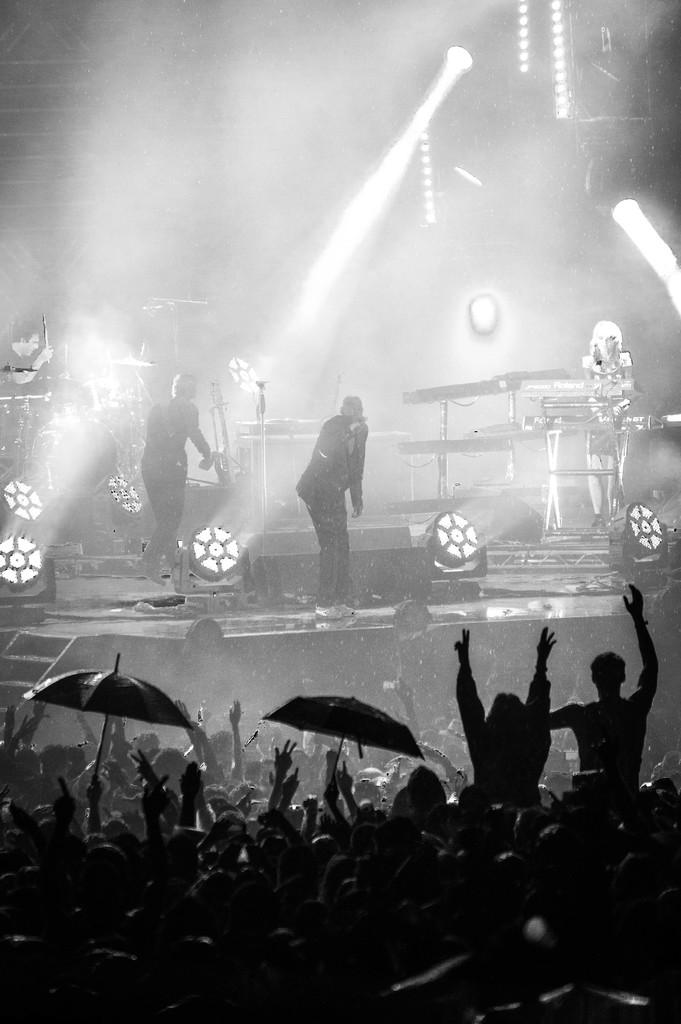How many people are in the image? There is a group of people in the image. What are some people doing in the image? Some people are holding umbrellas. What can be seen in the background of the image? Musical instruments, lights, and smoke are visible in the background. What type of club can be seen in the image? There is no club present in the image. How many things are visible in the image? It is not clear what "things" refers to in this context, but the image contains a group of people, umbrellas, musical instruments, lights, and smoke. What is the nose of the person in the image doing? There is no specific person mentioned in the image, and it is not possible to determine the actions of a person's nose from the provided facts. 